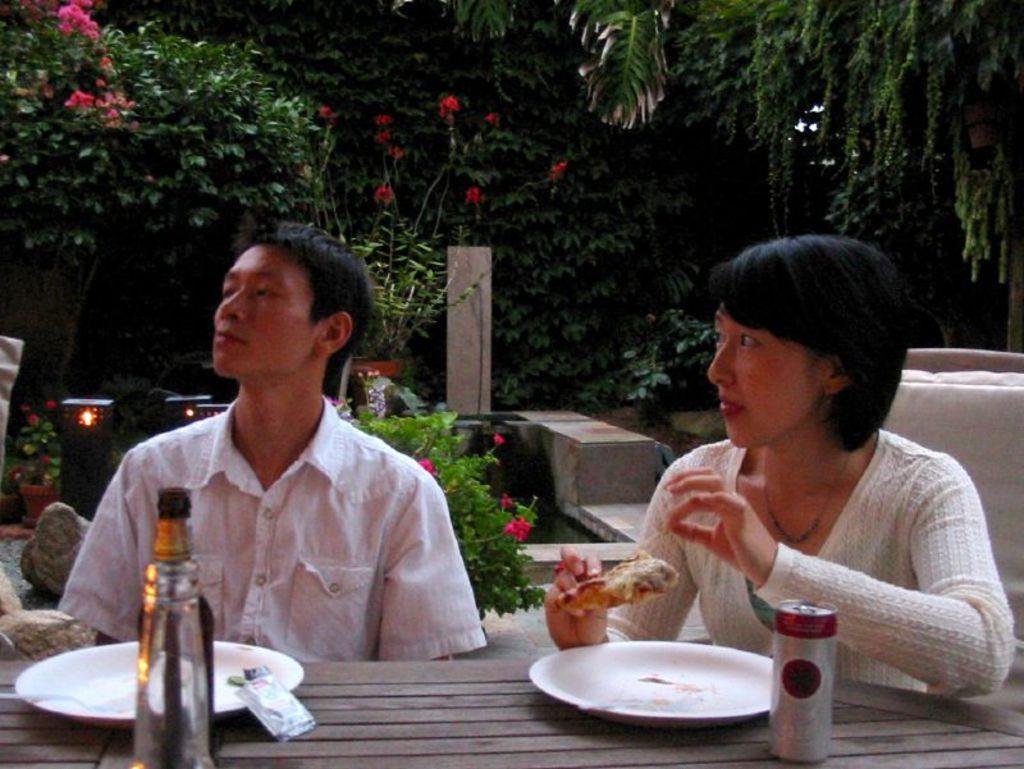Could you give a brief overview of what you see in this image? In this image I see a man and a woman and both of them are sitting in front of a table and I can also see that this woman is holding food in her hand and on the tables I see the plates, a bottle and a can. In the background I see the plants and the trees. 